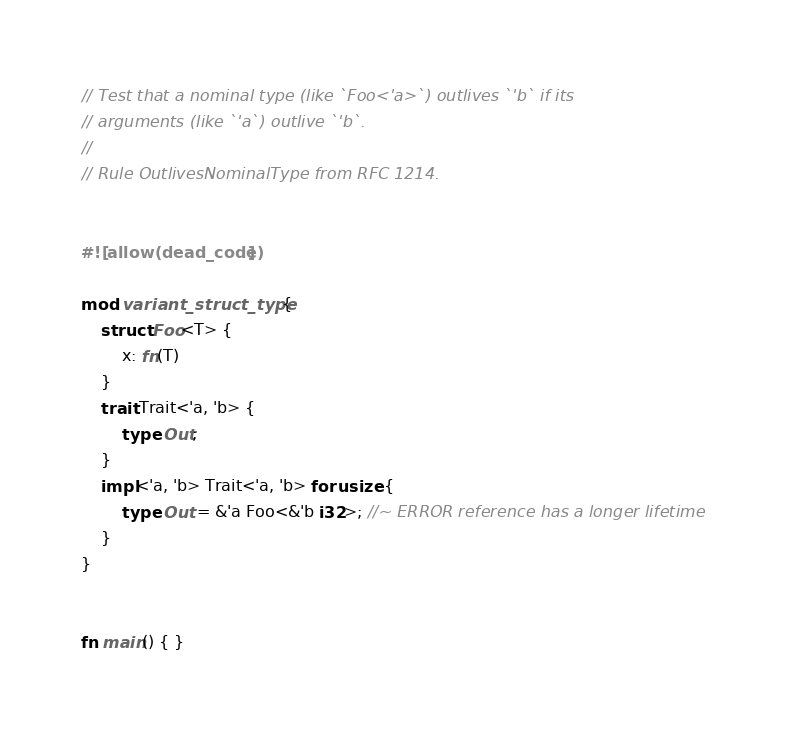Convert code to text. <code><loc_0><loc_0><loc_500><loc_500><_Rust_>// Test that a nominal type (like `Foo<'a>`) outlives `'b` if its
// arguments (like `'a`) outlive `'b`.
//
// Rule OutlivesNominalType from RFC 1214.


#![allow(dead_code)]

mod variant_struct_type {
    struct Foo<T> {
        x: fn(T)
    }
    trait Trait<'a, 'b> {
        type Out;
    }
    impl<'a, 'b> Trait<'a, 'b> for usize {
        type Out = &'a Foo<&'b i32>; //~ ERROR reference has a longer lifetime
    }
}


fn main() { }
</code> 